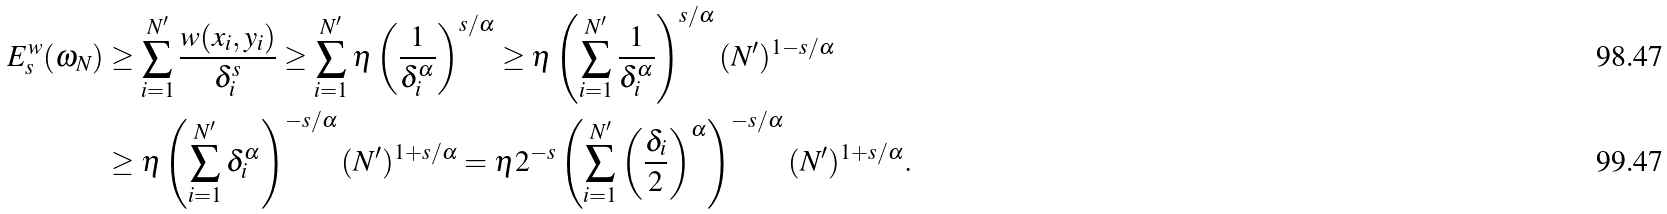<formula> <loc_0><loc_0><loc_500><loc_500>E _ { s } ^ { w } ( \omega _ { N } ) & \geq \sum _ { i = 1 } ^ { N ^ { \prime } } \frac { w ( x _ { i } , y _ { i } ) } { \delta _ { i } ^ { s } } \geq \sum _ { i = 1 } ^ { N ^ { \prime } } \eta \left ( \frac { 1 } { \delta _ { i } ^ { \alpha } } \right ) ^ { s / \alpha } \geq \eta \left ( \sum _ { i = 1 } ^ { N ^ { \prime } } \frac { 1 } { \delta _ { i } ^ { \alpha } } \right ) ^ { s / \alpha } ( N ^ { \prime } ) ^ { 1 - s / \alpha } \\ & \geq \eta \left ( \sum _ { i = 1 } ^ { N ^ { \prime } } \delta _ { i } ^ { \alpha } \right ) ^ { - s / \alpha } ( N ^ { \prime } ) ^ { 1 + s / \alpha } = \eta 2 ^ { - s } \left ( \sum _ { i = 1 } ^ { N ^ { \prime } } \left ( \frac { \delta _ { i } } { 2 } \right ) ^ { \alpha } \right ) ^ { - s / \alpha } ( N ^ { \prime } ) ^ { 1 + s / \alpha } .</formula> 